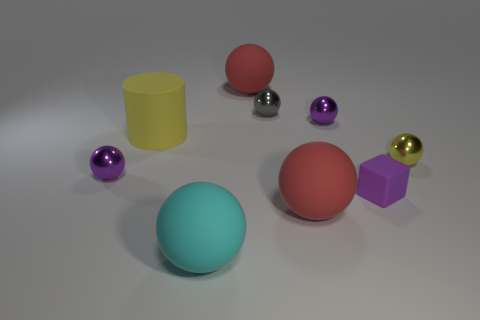How many things are either big red rubber balls in front of the large yellow matte cylinder or big matte cylinders?
Give a very brief answer. 2. Is there a large yellow thing that has the same shape as the tiny gray metallic object?
Your answer should be very brief. No. What is the shape of the yellow thing right of the small purple ball right of the big cyan rubber sphere?
Provide a succinct answer. Sphere. How many cubes are either cyan rubber objects or small purple matte objects?
Offer a terse response. 1. There is a small object that is the same color as the big rubber cylinder; what is it made of?
Keep it short and to the point. Metal. There is a yellow metal thing on the right side of the cylinder; does it have the same shape as the red thing in front of the big yellow rubber thing?
Your answer should be compact. Yes. What is the color of the shiny sphere that is right of the gray shiny sphere and to the left of the tiny yellow ball?
Provide a short and direct response. Purple. Do the block and the metallic ball that is right of the small matte cube have the same color?
Your response must be concise. No. What size is the shiny object that is both on the left side of the small yellow shiny sphere and in front of the large yellow thing?
Your response must be concise. Small. What number of other objects are the same color as the big cylinder?
Provide a succinct answer. 1. 